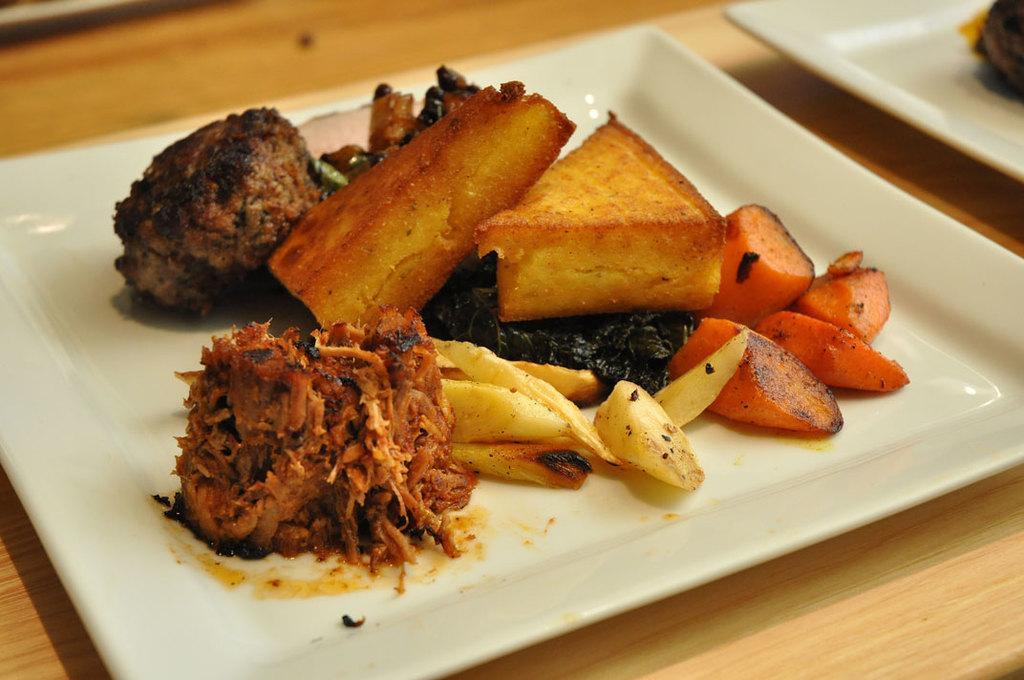How would you summarize this image in a sentence or two? As we can see in the image there is a table. On table there are white color plates. In plates there are dishes. 